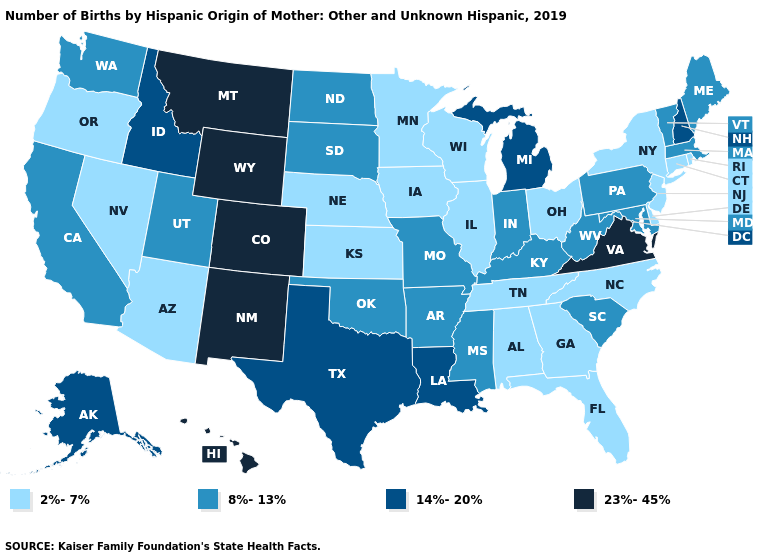What is the highest value in states that border South Dakota?
Write a very short answer. 23%-45%. What is the lowest value in states that border Minnesota?
Short answer required. 2%-7%. Which states have the lowest value in the West?
Short answer required. Arizona, Nevada, Oregon. Does Washington have the highest value in the West?
Keep it brief. No. Among the states that border Nevada , which have the highest value?
Give a very brief answer. Idaho. Name the states that have a value in the range 14%-20%?
Short answer required. Alaska, Idaho, Louisiana, Michigan, New Hampshire, Texas. What is the lowest value in the West?
Be succinct. 2%-7%. What is the value of Kansas?
Short answer required. 2%-7%. Does Delaware have the same value as Missouri?
Concise answer only. No. Does the map have missing data?
Keep it brief. No. What is the lowest value in the South?
Answer briefly. 2%-7%. Which states have the highest value in the USA?
Concise answer only. Colorado, Hawaii, Montana, New Mexico, Virginia, Wyoming. What is the lowest value in states that border Wisconsin?
Be succinct. 2%-7%. What is the value of Oregon?
Answer briefly. 2%-7%. What is the value of Ohio?
Short answer required. 2%-7%. 